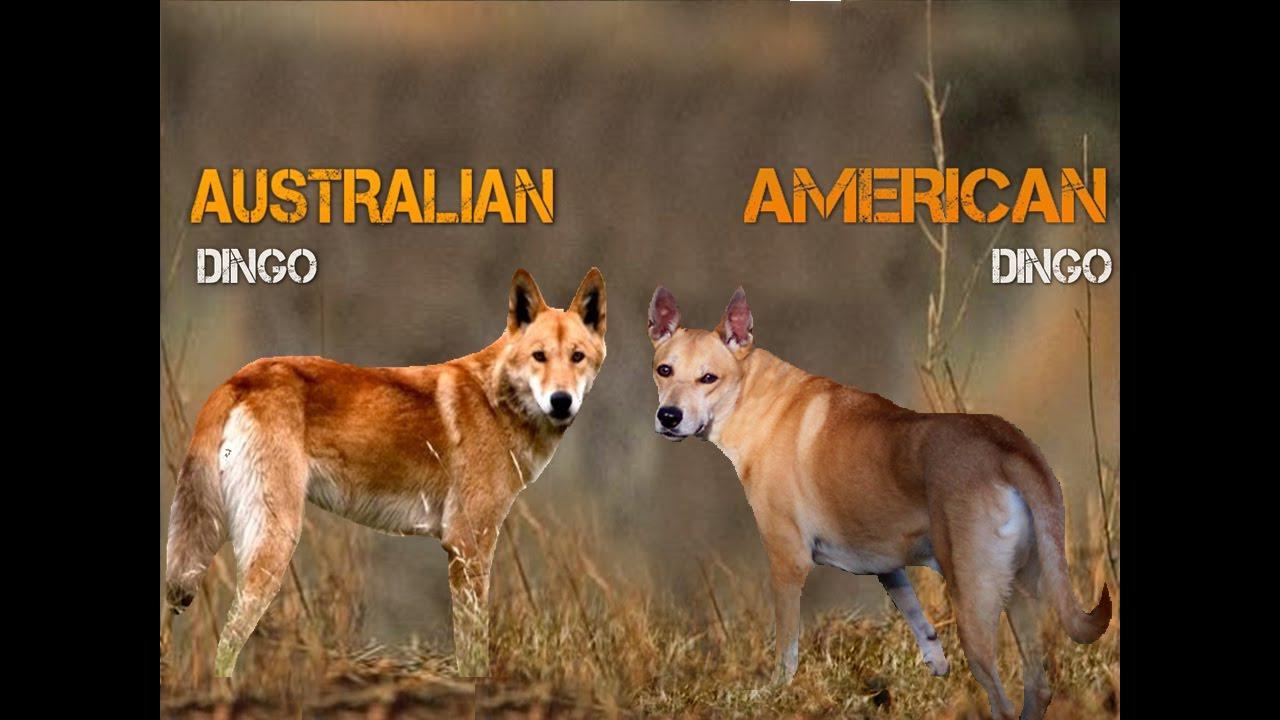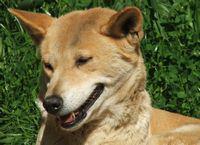The first image is the image on the left, the second image is the image on the right. Examine the images to the left and right. Is the description "There are two dogs in the pair of images." accurate? Answer yes or no. No. The first image is the image on the left, the second image is the image on the right. Considering the images on both sides, is "Each image contains exactly one dingo, and no dog looks levelly at the camera." valid? Answer yes or no. No. 